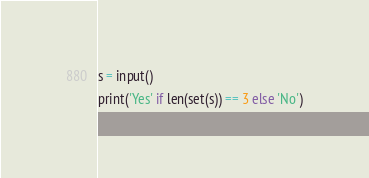Convert code to text. <code><loc_0><loc_0><loc_500><loc_500><_Python_>
s = input()
print('Yes' if len(set(s)) == 3 else 'No')</code> 